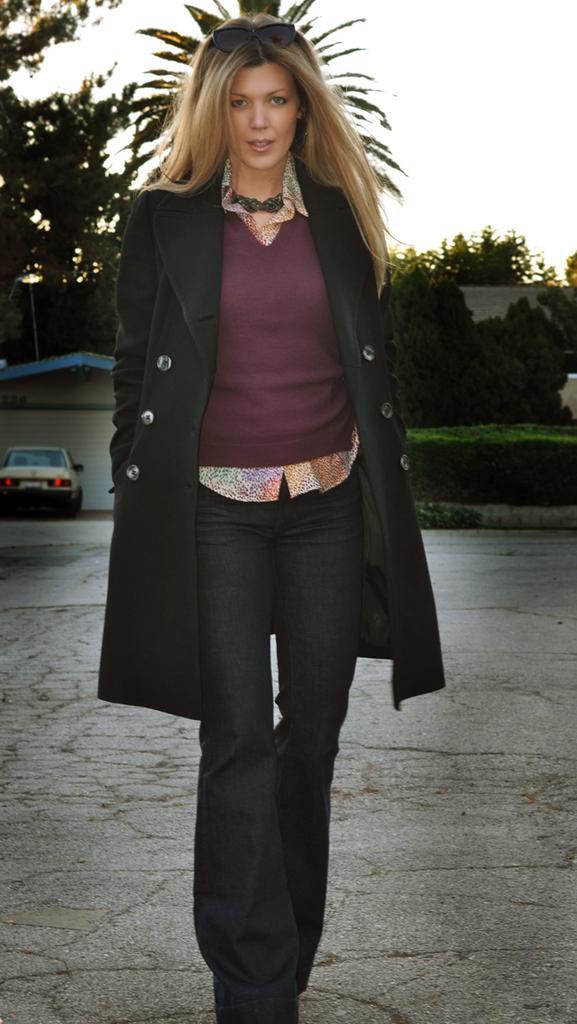How would you summarize this image in a sentence or two? In the image we can see a woman standing, wearing clothes and goggles. We can see a vehicle, footpath, plant, trees, building and a sky. 